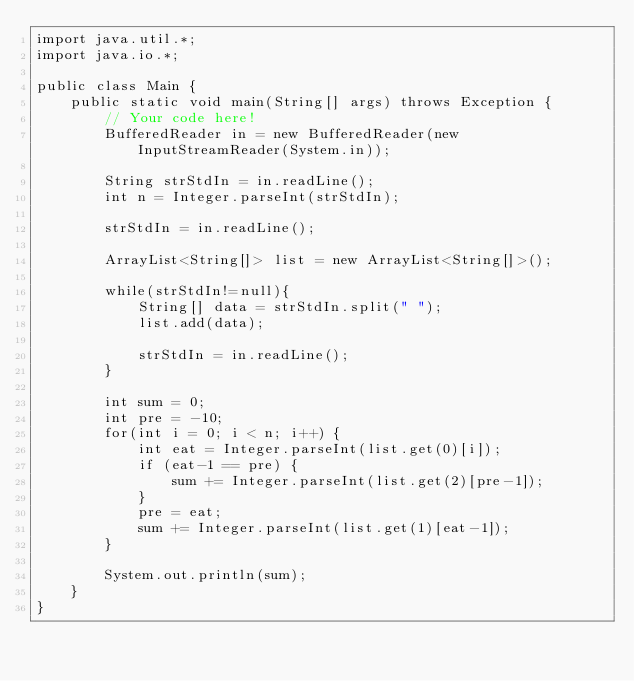<code> <loc_0><loc_0><loc_500><loc_500><_Java_>import java.util.*;
import java.io.*;

public class Main {
    public static void main(String[] args) throws Exception {
        // Your code here!
        BufferedReader in = new BufferedReader(new InputStreamReader(System.in));
        
        String strStdIn = in.readLine();
        int n = Integer.parseInt(strStdIn);
        
        strStdIn = in.readLine();
        
        ArrayList<String[]> list = new ArrayList<String[]>();
        
        while(strStdIn!=null){ 
            String[] data = strStdIn.split(" ");
            list.add(data);

            strStdIn = in.readLine();
        }
        
        int sum = 0;
        int pre = -10;
        for(int i = 0; i < n; i++) {
            int eat = Integer.parseInt(list.get(0)[i]);
            if (eat-1 == pre) {
                sum += Integer.parseInt(list.get(2)[pre-1]);
            }
            pre = eat;
            sum += Integer.parseInt(list.get(1)[eat-1]);
        }
        
        System.out.println(sum);
    }
}</code> 